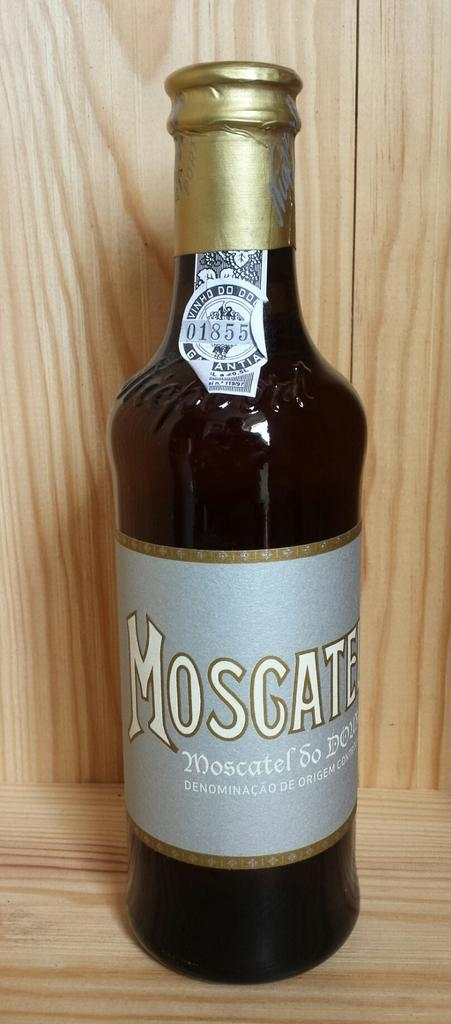<image>
Relay a brief, clear account of the picture shown. a bottle of wine that is called 'moscate' 